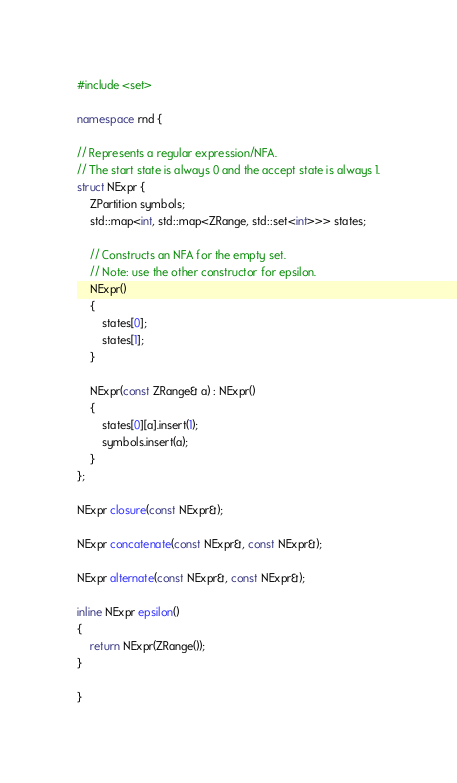Convert code to text. <code><loc_0><loc_0><loc_500><loc_500><_C++_>#include <set>

namespace rnd {

// Represents a regular expression/NFA.
// The start state is always 0 and the accept state is always 1.
struct NExpr {
    ZPartition symbols;
    std::map<int, std::map<ZRange, std::set<int>>> states;

    // Constructs an NFA for the empty set.
    // Note: use the other constructor for epsilon.
    NExpr()
    {
        states[0];
        states[1];
    }

    NExpr(const ZRange& a) : NExpr()
    {
        states[0][a].insert(1);
        symbols.insert(a);
    }
};

NExpr closure(const NExpr&);

NExpr concatenate(const NExpr&, const NExpr&);

NExpr alternate(const NExpr&, const NExpr&);

inline NExpr epsilon()
{
    return NExpr(ZRange());
}

}
</code> 